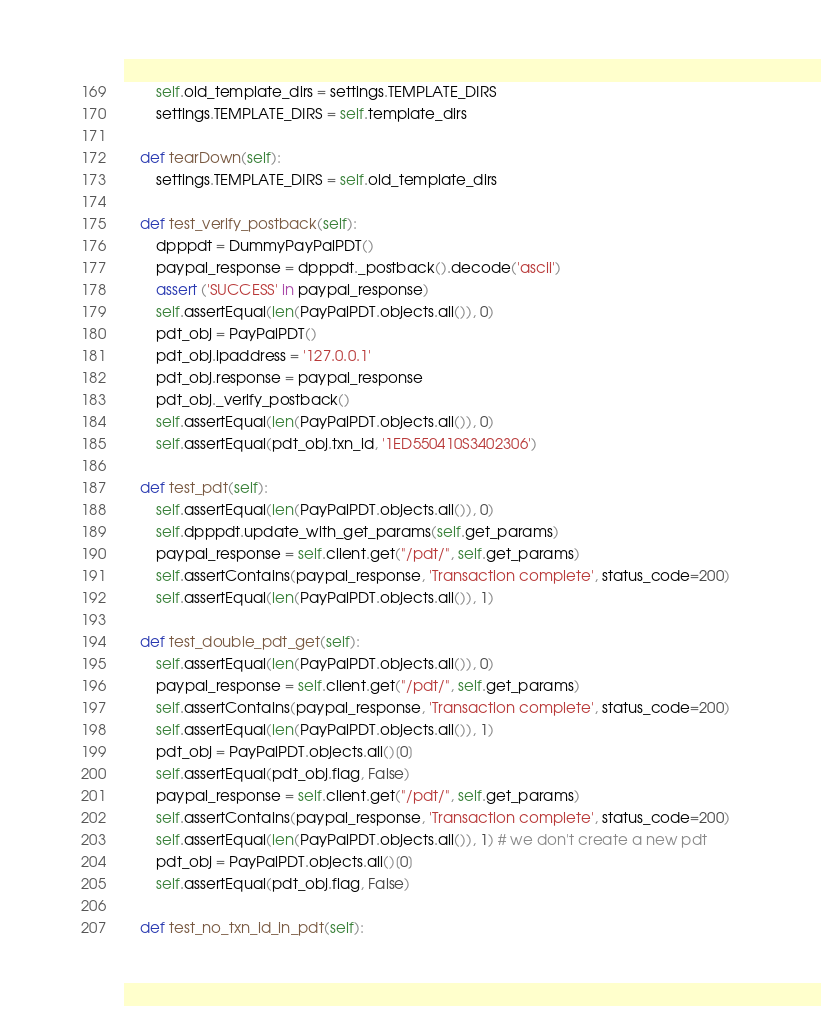Convert code to text. <code><loc_0><loc_0><loc_500><loc_500><_Python_>        self.old_template_dirs = settings.TEMPLATE_DIRS
        settings.TEMPLATE_DIRS = self.template_dirs

    def tearDown(self):
        settings.TEMPLATE_DIRS = self.old_template_dirs

    def test_verify_postback(self):
        dpppdt = DummyPayPalPDT()
        paypal_response = dpppdt._postback().decode('ascii')
        assert ('SUCCESS' in paypal_response)
        self.assertEqual(len(PayPalPDT.objects.all()), 0)
        pdt_obj = PayPalPDT()
        pdt_obj.ipaddress = '127.0.0.1'
        pdt_obj.response = paypal_response
        pdt_obj._verify_postback()
        self.assertEqual(len(PayPalPDT.objects.all()), 0)
        self.assertEqual(pdt_obj.txn_id, '1ED550410S3402306')

    def test_pdt(self):
        self.assertEqual(len(PayPalPDT.objects.all()), 0)
        self.dpppdt.update_with_get_params(self.get_params)
        paypal_response = self.client.get("/pdt/", self.get_params)
        self.assertContains(paypal_response, 'Transaction complete', status_code=200)
        self.assertEqual(len(PayPalPDT.objects.all()), 1)

    def test_double_pdt_get(self):
        self.assertEqual(len(PayPalPDT.objects.all()), 0)
        paypal_response = self.client.get("/pdt/", self.get_params)
        self.assertContains(paypal_response, 'Transaction complete', status_code=200)
        self.assertEqual(len(PayPalPDT.objects.all()), 1)
        pdt_obj = PayPalPDT.objects.all()[0]
        self.assertEqual(pdt_obj.flag, False)
        paypal_response = self.client.get("/pdt/", self.get_params)
        self.assertContains(paypal_response, 'Transaction complete', status_code=200)
        self.assertEqual(len(PayPalPDT.objects.all()), 1) # we don't create a new pdt        
        pdt_obj = PayPalPDT.objects.all()[0]
        self.assertEqual(pdt_obj.flag, False)

    def test_no_txn_id_in_pdt(self):</code> 